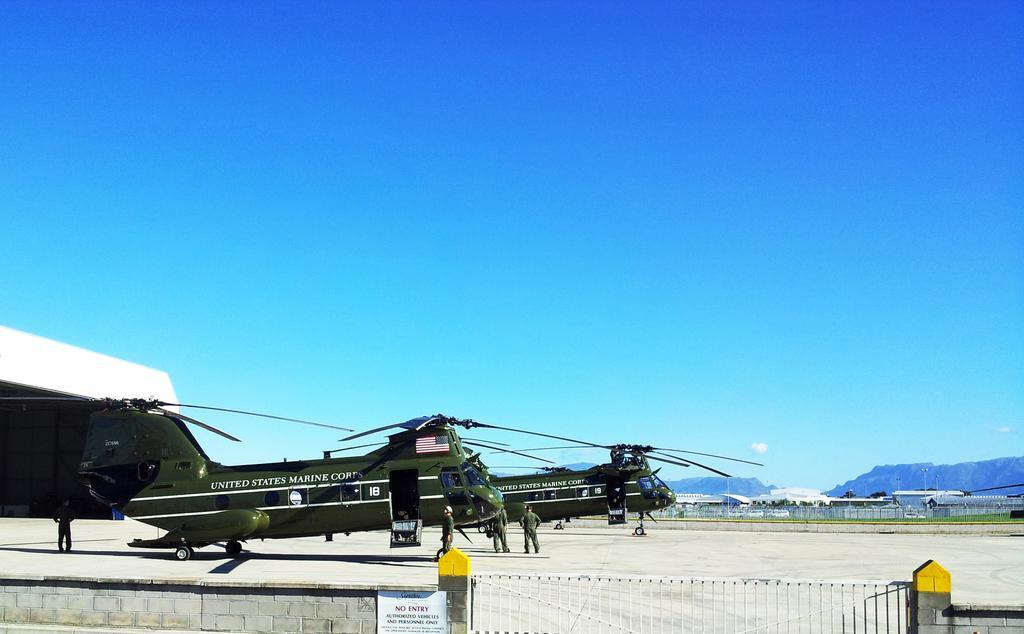Can you describe this image briefly? In this image we can see few air crafts and people on the ground, we can see some poles, buildings, lights, tree, grille and the wall, on the wall we can see a board with some text, in the background we can see the wall. 